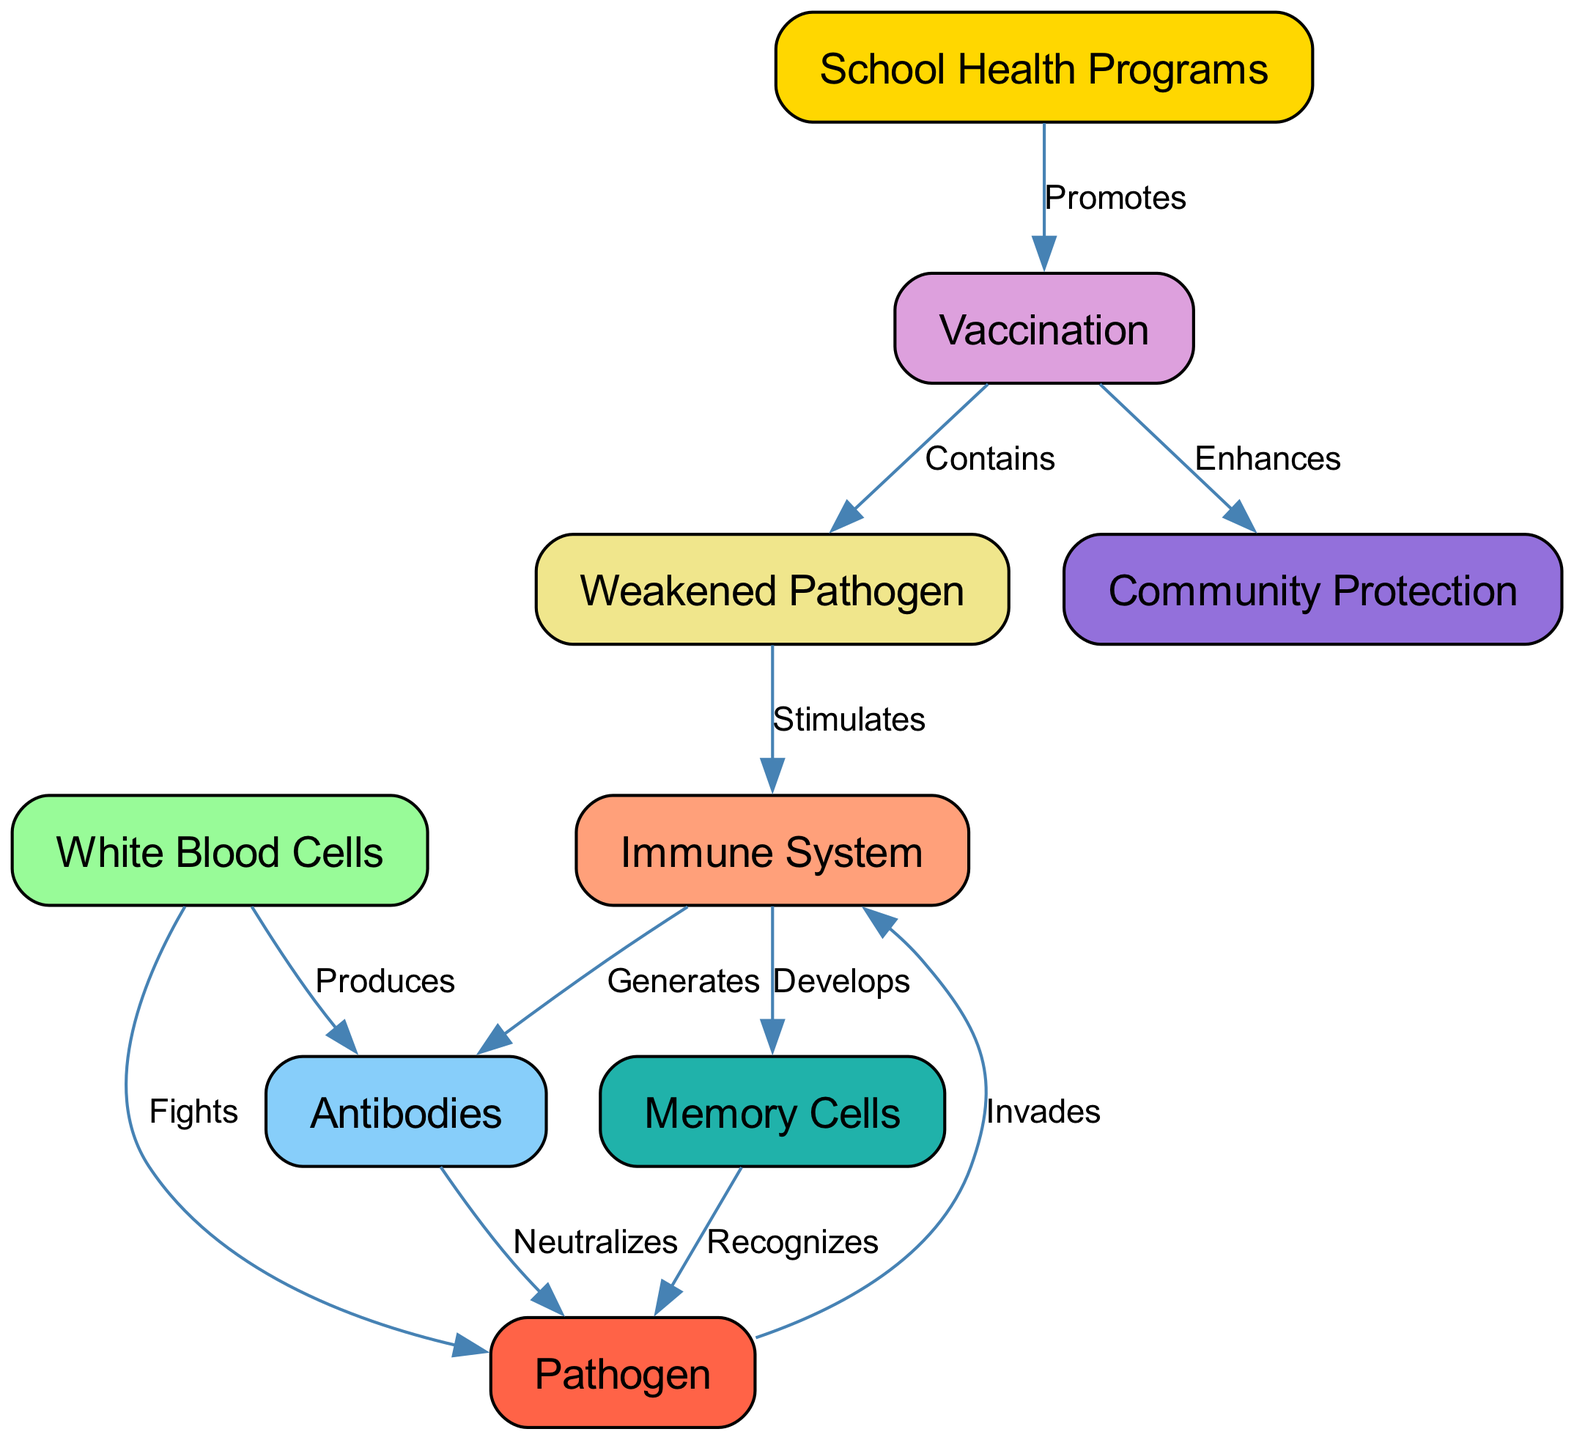What is the main function of white blood cells? White blood cells are depicted as fighting pathogens in the diagram. This shows their role in the immune response, where they seek out and destroy invading pathogens.
Answer: Fights How many nodes are represented in the diagram? By counting the entries in the nodes list, we find a total of nine unique nodes included in the diagram.
Answer: 9 What does vaccination contain? The relationship labeled "Contains" shows that vaccination includes a weakened pathogen, indicating that this is a key component for stimulating an immune response.
Answer: Weakened Pathogen How do memory cells interact with pathogens? The diagram indicates that memory cells recognize pathogens, suggesting that they have memory of past infections and help initiate a quicker response upon re-exposure.
Answer: Recognizes What does school health programs promote? The directional edge labeled "Promotes" connects school health programs to vaccination, illustrating that the programs advocate for vaccination as a means to protect children’s health.
Answer: Vaccination What enhances community protection? The diagram shows that vaccination enhances community protection, highlighting the role of widespread vaccination in creating herd immunity in the broader community.
Answer: Vaccination Which component generates antibodies? The immune system is shown to generate antibodies, demonstrating its function in producing specific proteins that help in neutralizing pathogens.
Answer: Immune System What is the relationship between vaccinations and school health programs? The "+Promotes+" relationship indicates that school health programs have a proactive approach in encouraging vaccinations among students to ensure their health.
Answer: Promotes What does the immune system develop in response to pathogens? The diagram clearly states that the immune system develops memory cells, reflecting its adaptive response to remember pathogens for future defense.
Answer: Memory Cells 